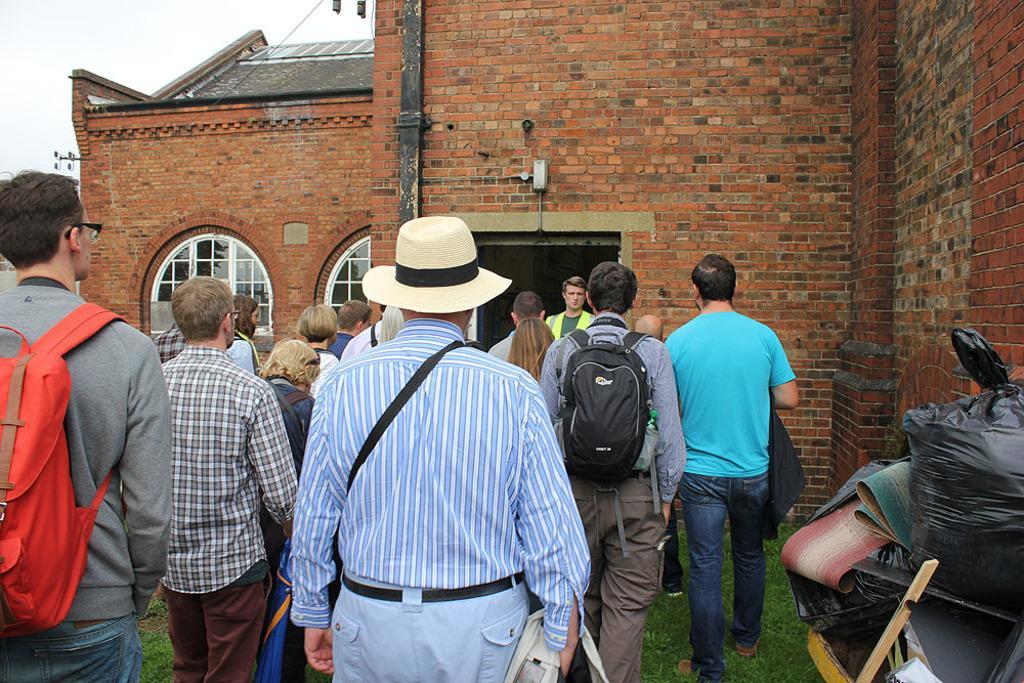Could you give a brief overview of what you see in this image? This image is taken outdoors. At the bottom of the image there is a ground with grass on it. In the background there is a building with walls, windows, a roof and a door. At the top of the image there is a sky with clouds. On the right side of the image there are a few things on the ground. In the middle of the image a few people are standing on the ground and a few have worn backpacks. 